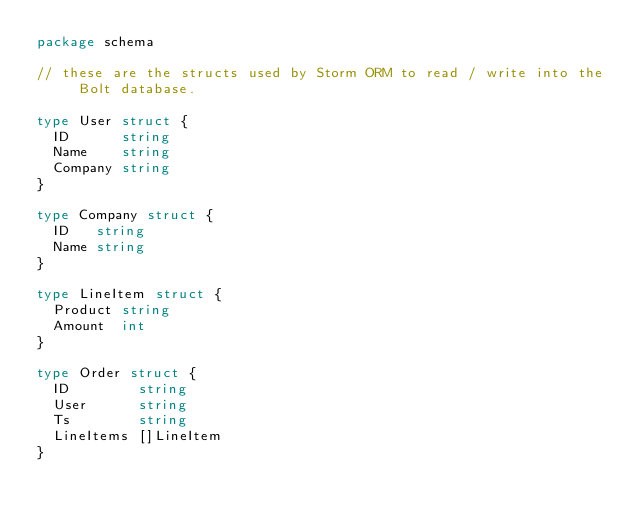<code> <loc_0><loc_0><loc_500><loc_500><_Go_>package schema

// these are the structs used by Storm ORM to read / write into the Bolt database.

type User struct {
	ID      string
	Name    string
	Company string
}

type Company struct {
	ID   string
	Name string
}

type LineItem struct {
	Product string
	Amount  int
}

type Order struct {
	ID        string
	User      string
	Ts        string
	LineItems []LineItem
}
</code> 